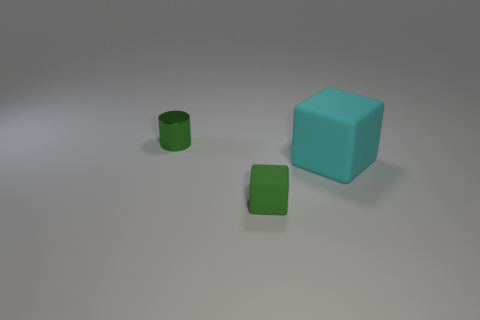Add 2 cyan cylinders. How many objects exist? 5 Subtract all cylinders. How many objects are left? 2 Add 3 metallic objects. How many metallic objects exist? 4 Subtract 0 brown balls. How many objects are left? 3 Subtract all big gray objects. Subtract all large cyan blocks. How many objects are left? 2 Add 1 green matte objects. How many green matte objects are left? 2 